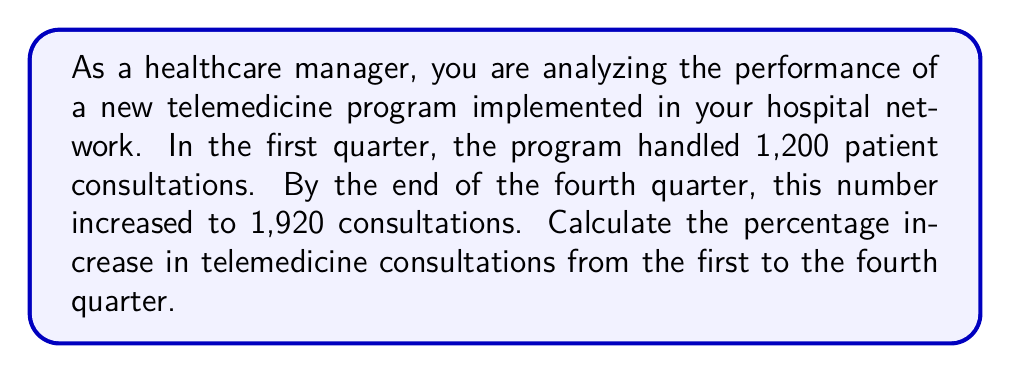Can you answer this question? To calculate the percentage increase, we need to follow these steps:

1. Calculate the absolute increase in consultations:
   $\text{Increase} = \text{Final value} - \text{Initial value}$
   $\text{Increase} = 1,920 - 1,200 = 720$ consultations

2. Calculate the percentage increase using the formula:
   $$\text{Percentage increase} = \frac{\text{Increase}}{\text{Initial value}} \times 100\%$$

3. Substitute the values into the formula:
   $$\text{Percentage increase} = \frac{720}{1,200} \times 100\%$$

4. Simplify the fraction:
   $$\text{Percentage increase} = \frac{3}{5} \times 100\%$$

5. Calculate the final result:
   $$\text{Percentage increase} = 0.6 \times 100\% = 60\%$$

Therefore, the percentage increase in telemedicine consultations from the first to the fourth quarter is 60%.
Answer: 60% 